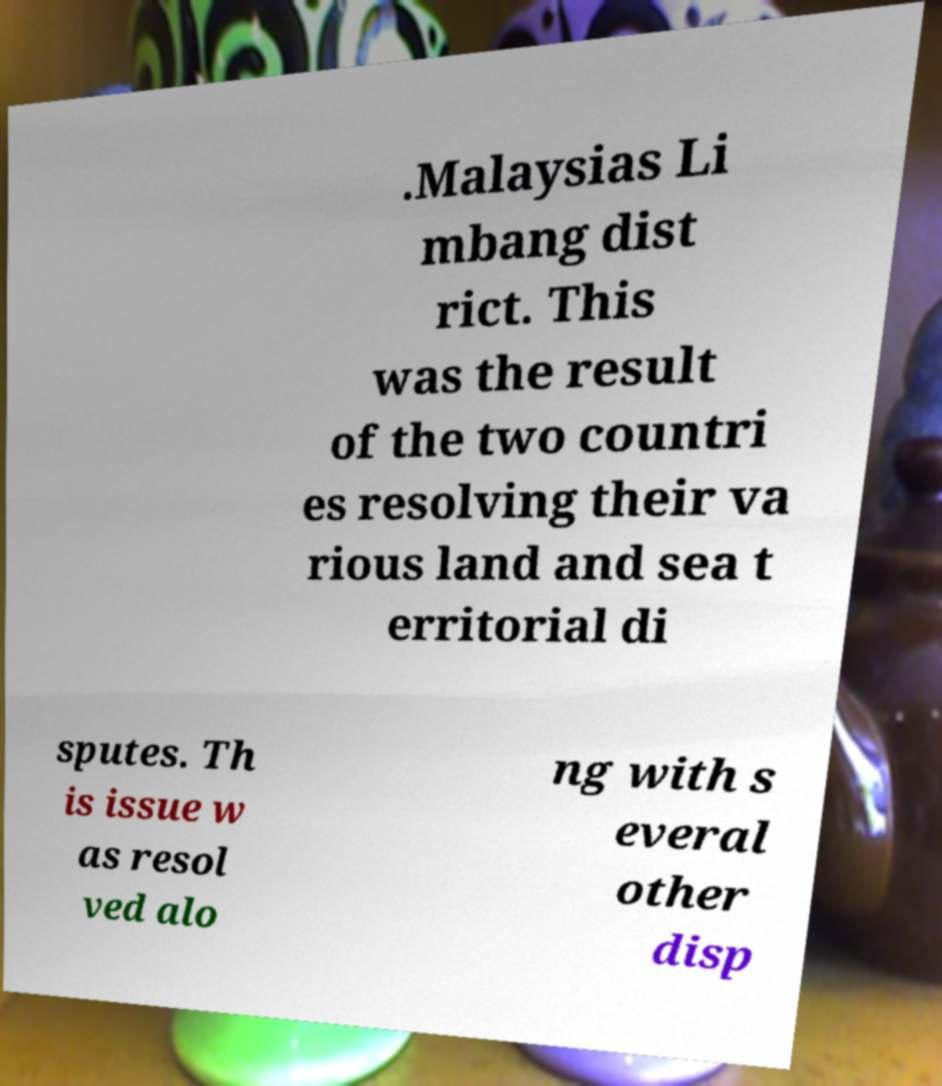Please read and relay the text visible in this image. What does it say? .Malaysias Li mbang dist rict. This was the result of the two countri es resolving their va rious land and sea t erritorial di sputes. Th is issue w as resol ved alo ng with s everal other disp 